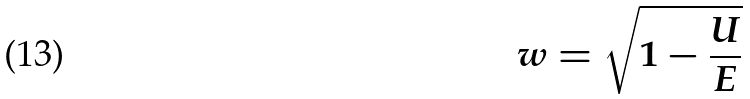<formula> <loc_0><loc_0><loc_500><loc_500>w = \sqrt { 1 - \frac { U } { E } }</formula> 